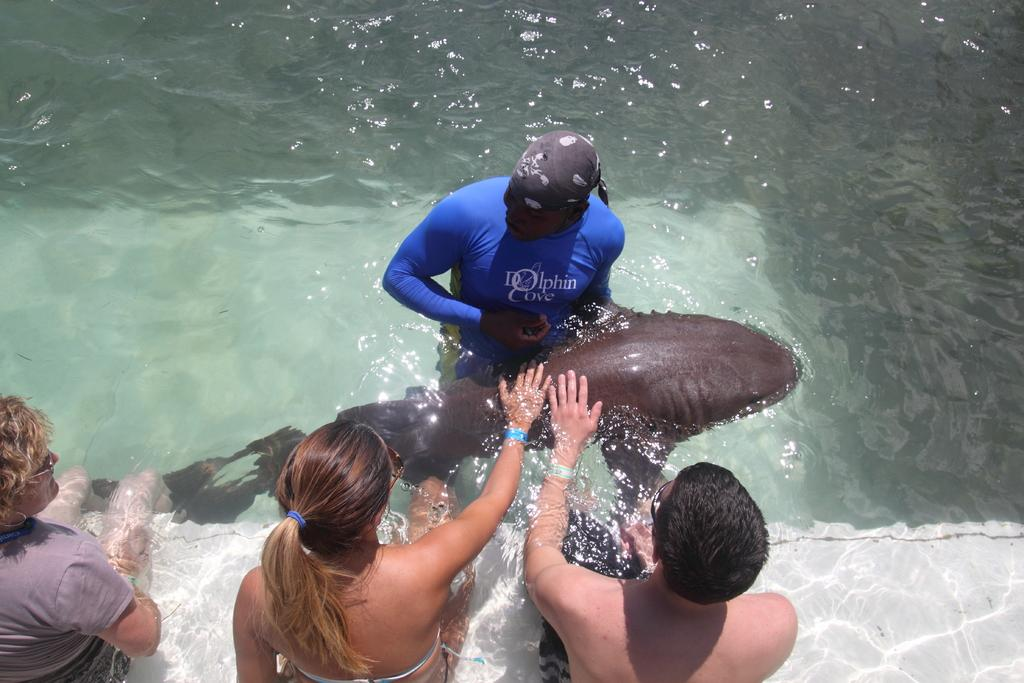What is the primary element in the image? There is water in the image. What are the people in the image doing? The people are in the water. Can you describe the aquatic animal in the image? There is a black-colored aquatic animal in the image. What type of berry can be seen growing on the slope in the image? There is no slope or berry present in the image; it features water with people and a black-colored aquatic animal. What is the cause of the throat irritation experienced by the person in the image? There is no person experiencing throat irritation in the image. 